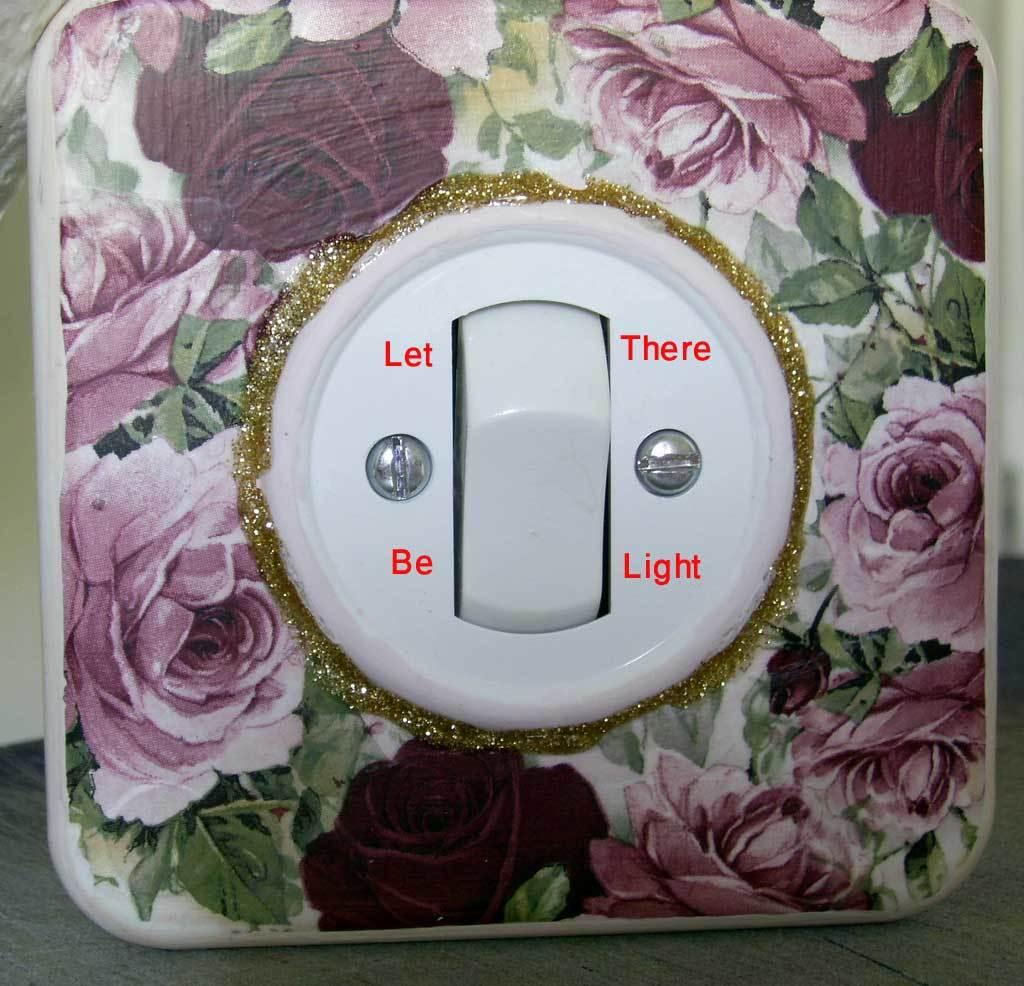What is the main object in the image? There is a switchboard in the image. What can be seen on the switchboard? The switchboard has text on it. What color is the surface at the bottom of the image? The surface at the bottom of the image is grey. What type of texture does the father's shirt have in the image? There is no father or shirt present in the image; it only features a switchboard and a grey surface. 